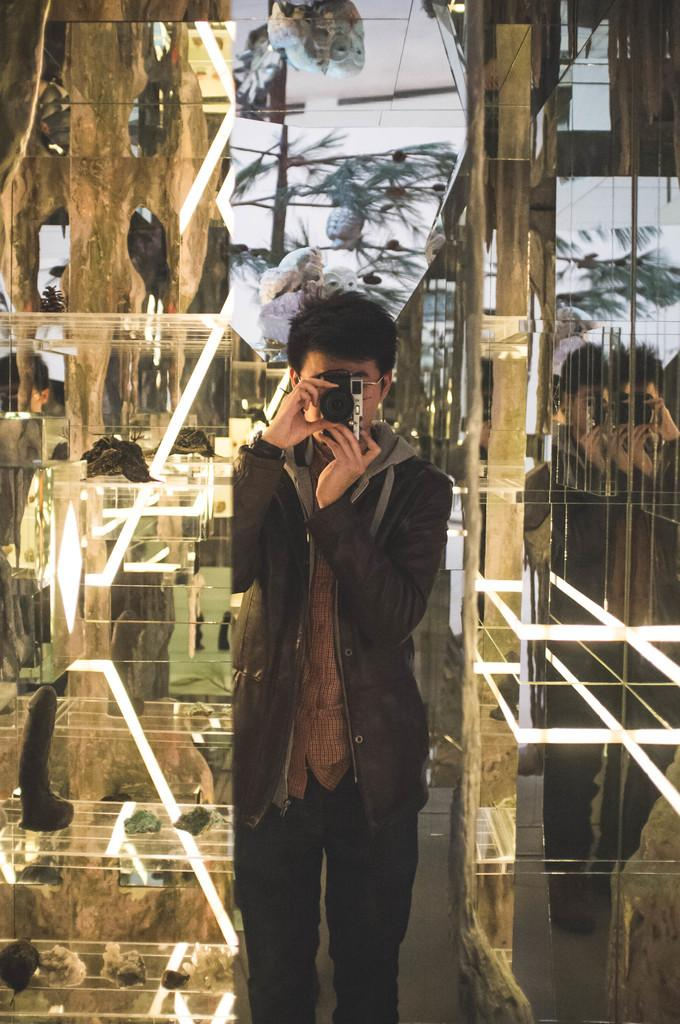What is the main subject of the image? There is a man standing in the middle of the image. What is the man holding in his hands? The man is holding a camera in his hands. What can be seen in the background of the image? There are glass doors and trees visible in the background of the image. How many facts can be found on the earth in the image? There is no reference to facts or the earth in the image; it features a man holding a camera with a background of glass doors and trees. 